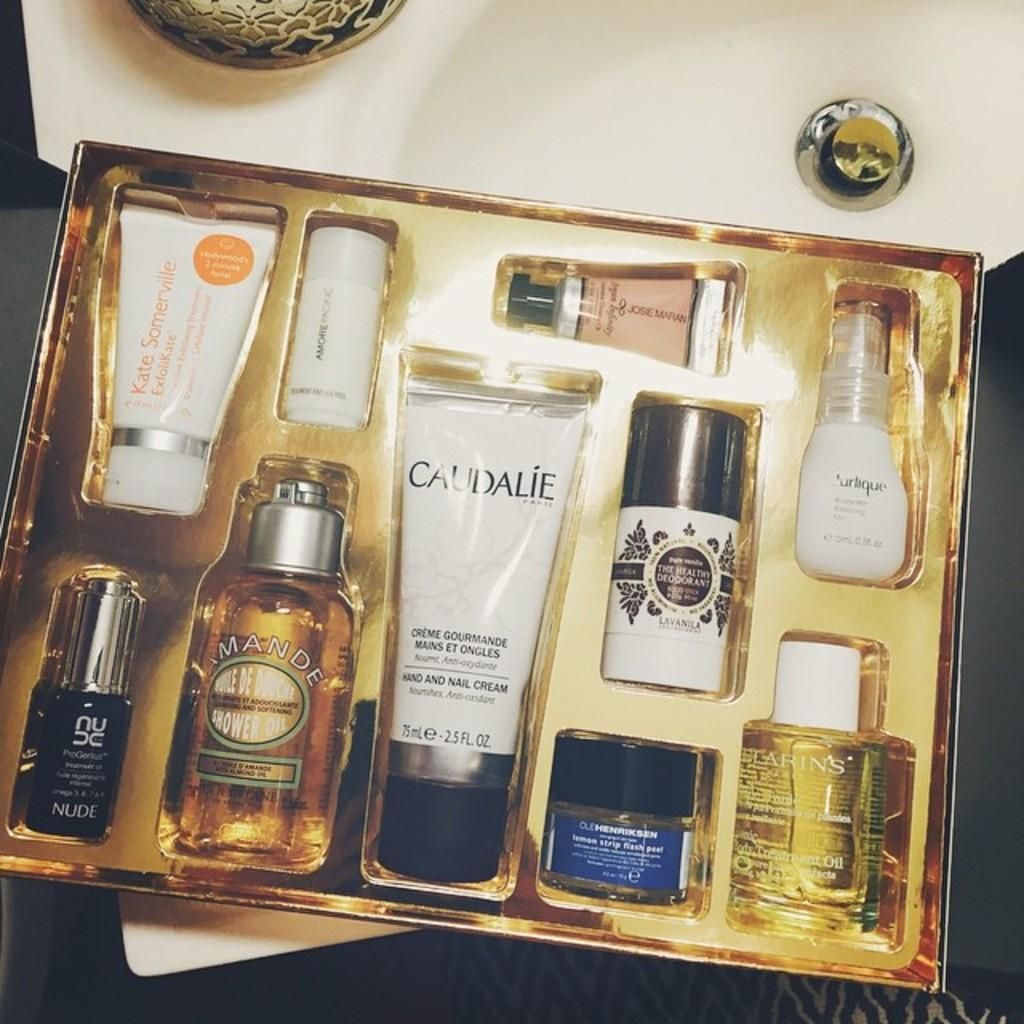Provide a one-sentence caption for the provided image. A skincare set that includes Kate Somerville and Caudalie products among others. 